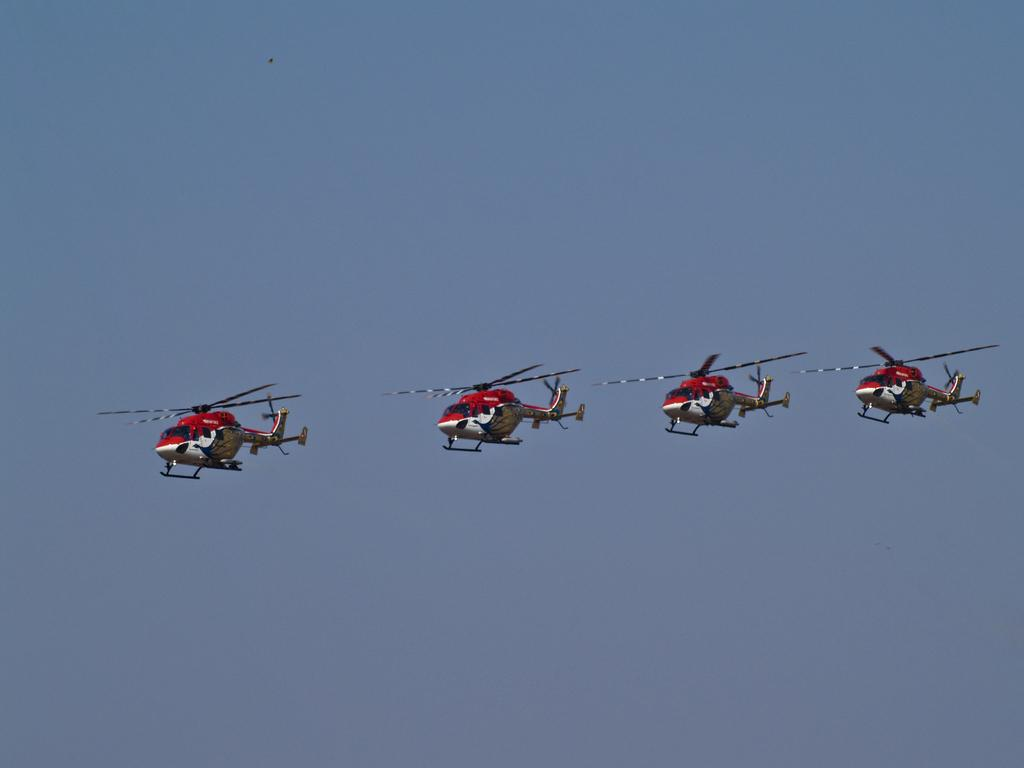How many helicopters are visible in the image? There are four helicopters in the image. What are the helicopters doing in the image? The helicopters are flying in the sky. What is the color of the sky in the image? The sky is light blue in color. What type of creature can be seen sitting on the beam in the image? There is no beam or creature present in the image; it features four helicopters flying in the light blue sky. 